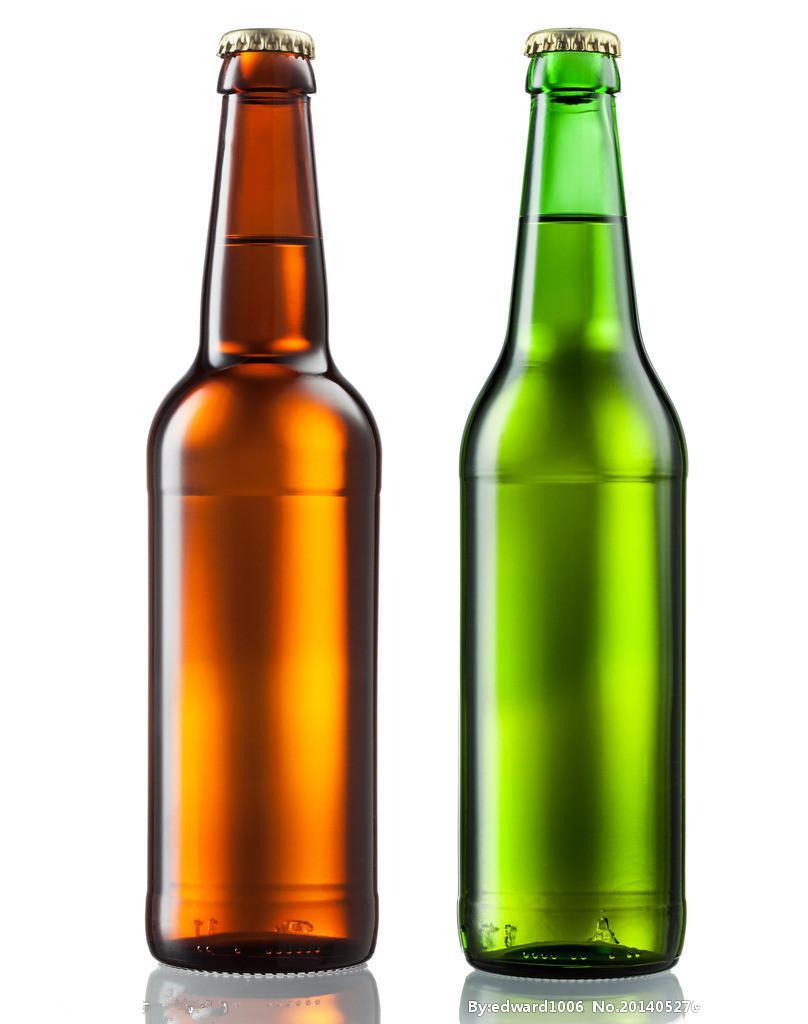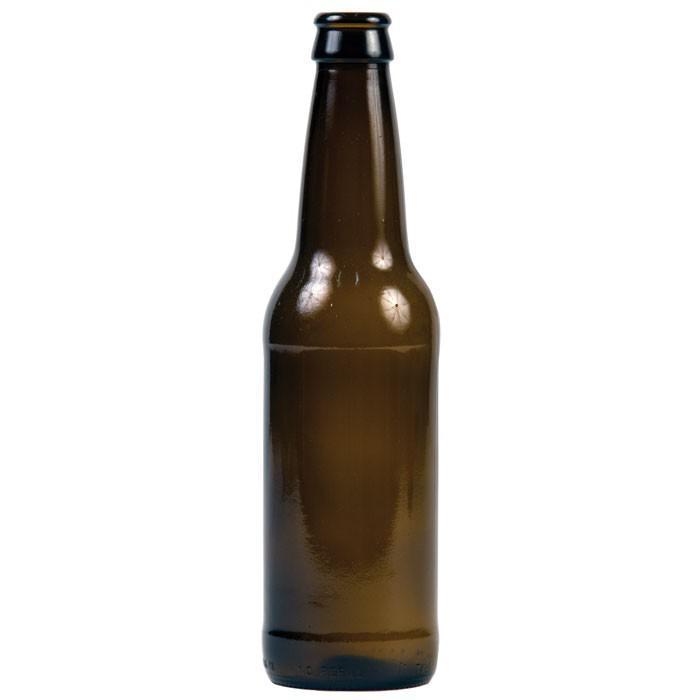The first image is the image on the left, the second image is the image on the right. Evaluate the accuracy of this statement regarding the images: "One image is a single dark brown glass bottle.". Is it true? Answer yes or no. Yes. 